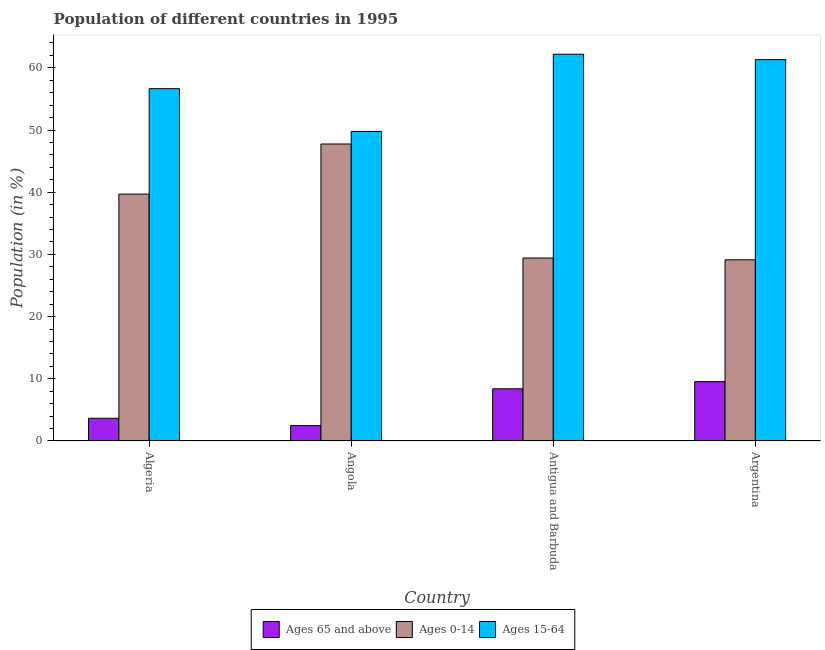How many groups of bars are there?
Your answer should be compact. 4. Are the number of bars on each tick of the X-axis equal?
Provide a short and direct response. Yes. How many bars are there on the 2nd tick from the left?
Offer a very short reply. 3. What is the label of the 2nd group of bars from the left?
Give a very brief answer. Angola. What is the percentage of population within the age-group 0-14 in Argentina?
Give a very brief answer. 29.13. Across all countries, what is the maximum percentage of population within the age-group 0-14?
Keep it short and to the point. 47.75. Across all countries, what is the minimum percentage of population within the age-group 0-14?
Your answer should be very brief. 29.13. In which country was the percentage of population within the age-group of 65 and above maximum?
Your response must be concise. Argentina. In which country was the percentage of population within the age-group 15-64 minimum?
Ensure brevity in your answer.  Angola. What is the total percentage of population within the age-group 15-64 in the graph?
Keep it short and to the point. 229.94. What is the difference between the percentage of population within the age-group 0-14 in Angola and that in Argentina?
Give a very brief answer. 18.62. What is the difference between the percentage of population within the age-group 0-14 in Angola and the percentage of population within the age-group 15-64 in Antigua and Barbuda?
Your response must be concise. -14.44. What is the average percentage of population within the age-group of 65 and above per country?
Offer a very short reply. 6.01. What is the difference between the percentage of population within the age-group 0-14 and percentage of population within the age-group 15-64 in Antigua and Barbuda?
Give a very brief answer. -32.77. What is the ratio of the percentage of population within the age-group of 65 and above in Angola to that in Argentina?
Your answer should be compact. 0.26. Is the difference between the percentage of population within the age-group 15-64 in Algeria and Angola greater than the difference between the percentage of population within the age-group 0-14 in Algeria and Angola?
Keep it short and to the point. Yes. What is the difference between the highest and the second highest percentage of population within the age-group of 65 and above?
Offer a very short reply. 1.16. What is the difference between the highest and the lowest percentage of population within the age-group 15-64?
Offer a terse response. 12.42. In how many countries, is the percentage of population within the age-group of 65 and above greater than the average percentage of population within the age-group of 65 and above taken over all countries?
Offer a very short reply. 2. Is the sum of the percentage of population within the age-group 15-64 in Angola and Antigua and Barbuda greater than the maximum percentage of population within the age-group of 65 and above across all countries?
Your answer should be compact. Yes. What does the 2nd bar from the left in Angola represents?
Provide a short and direct response. Ages 0-14. What does the 2nd bar from the right in Algeria represents?
Make the answer very short. Ages 0-14. Is it the case that in every country, the sum of the percentage of population within the age-group of 65 and above and percentage of population within the age-group 0-14 is greater than the percentage of population within the age-group 15-64?
Your answer should be very brief. No. How many countries are there in the graph?
Your answer should be very brief. 4. What is the difference between two consecutive major ticks on the Y-axis?
Offer a terse response. 10. Are the values on the major ticks of Y-axis written in scientific E-notation?
Offer a terse response. No. Where does the legend appear in the graph?
Provide a short and direct response. Bottom center. How are the legend labels stacked?
Keep it short and to the point. Horizontal. What is the title of the graph?
Your answer should be very brief. Population of different countries in 1995. What is the label or title of the X-axis?
Offer a very short reply. Country. What is the label or title of the Y-axis?
Make the answer very short. Population (in %). What is the Population (in %) of Ages 65 and above in Algeria?
Give a very brief answer. 3.65. What is the Population (in %) of Ages 0-14 in Algeria?
Provide a short and direct response. 39.7. What is the Population (in %) in Ages 15-64 in Algeria?
Give a very brief answer. 56.65. What is the Population (in %) of Ages 65 and above in Angola?
Your answer should be very brief. 2.47. What is the Population (in %) in Ages 0-14 in Angola?
Give a very brief answer. 47.75. What is the Population (in %) of Ages 15-64 in Angola?
Offer a very short reply. 49.78. What is the Population (in %) of Ages 65 and above in Antigua and Barbuda?
Offer a terse response. 8.39. What is the Population (in %) of Ages 0-14 in Antigua and Barbuda?
Offer a very short reply. 29.42. What is the Population (in %) in Ages 15-64 in Antigua and Barbuda?
Your answer should be very brief. 62.19. What is the Population (in %) of Ages 65 and above in Argentina?
Your response must be concise. 9.55. What is the Population (in %) of Ages 0-14 in Argentina?
Provide a short and direct response. 29.13. What is the Population (in %) in Ages 15-64 in Argentina?
Your answer should be compact. 61.32. Across all countries, what is the maximum Population (in %) of Ages 65 and above?
Provide a short and direct response. 9.55. Across all countries, what is the maximum Population (in %) in Ages 0-14?
Your response must be concise. 47.75. Across all countries, what is the maximum Population (in %) in Ages 15-64?
Make the answer very short. 62.19. Across all countries, what is the minimum Population (in %) in Ages 65 and above?
Your answer should be very brief. 2.47. Across all countries, what is the minimum Population (in %) in Ages 0-14?
Provide a succinct answer. 29.13. Across all countries, what is the minimum Population (in %) in Ages 15-64?
Make the answer very short. 49.78. What is the total Population (in %) of Ages 65 and above in the graph?
Offer a very short reply. 24.06. What is the total Population (in %) of Ages 0-14 in the graph?
Give a very brief answer. 146. What is the total Population (in %) of Ages 15-64 in the graph?
Your response must be concise. 229.94. What is the difference between the Population (in %) in Ages 65 and above in Algeria and that in Angola?
Give a very brief answer. 1.18. What is the difference between the Population (in %) in Ages 0-14 in Algeria and that in Angola?
Keep it short and to the point. -8.06. What is the difference between the Population (in %) in Ages 15-64 in Algeria and that in Angola?
Your response must be concise. 6.88. What is the difference between the Population (in %) in Ages 65 and above in Algeria and that in Antigua and Barbuda?
Your answer should be compact. -4.74. What is the difference between the Population (in %) in Ages 0-14 in Algeria and that in Antigua and Barbuda?
Give a very brief answer. 10.28. What is the difference between the Population (in %) of Ages 15-64 in Algeria and that in Antigua and Barbuda?
Keep it short and to the point. -5.54. What is the difference between the Population (in %) in Ages 65 and above in Algeria and that in Argentina?
Your answer should be very brief. -5.9. What is the difference between the Population (in %) of Ages 0-14 in Algeria and that in Argentina?
Provide a short and direct response. 10.56. What is the difference between the Population (in %) in Ages 15-64 in Algeria and that in Argentina?
Provide a succinct answer. -4.67. What is the difference between the Population (in %) of Ages 65 and above in Angola and that in Antigua and Barbuda?
Provide a short and direct response. -5.92. What is the difference between the Population (in %) of Ages 0-14 in Angola and that in Antigua and Barbuda?
Offer a very short reply. 18.34. What is the difference between the Population (in %) of Ages 15-64 in Angola and that in Antigua and Barbuda?
Provide a short and direct response. -12.42. What is the difference between the Population (in %) of Ages 65 and above in Angola and that in Argentina?
Ensure brevity in your answer.  -7.08. What is the difference between the Population (in %) in Ages 0-14 in Angola and that in Argentina?
Offer a terse response. 18.62. What is the difference between the Population (in %) in Ages 15-64 in Angola and that in Argentina?
Your answer should be very brief. -11.54. What is the difference between the Population (in %) in Ages 65 and above in Antigua and Barbuda and that in Argentina?
Your answer should be compact. -1.16. What is the difference between the Population (in %) of Ages 0-14 in Antigua and Barbuda and that in Argentina?
Offer a very short reply. 0.29. What is the difference between the Population (in %) of Ages 15-64 in Antigua and Barbuda and that in Argentina?
Offer a terse response. 0.87. What is the difference between the Population (in %) in Ages 65 and above in Algeria and the Population (in %) in Ages 0-14 in Angola?
Provide a succinct answer. -44.1. What is the difference between the Population (in %) of Ages 65 and above in Algeria and the Population (in %) of Ages 15-64 in Angola?
Provide a short and direct response. -46.12. What is the difference between the Population (in %) in Ages 0-14 in Algeria and the Population (in %) in Ages 15-64 in Angola?
Your answer should be very brief. -10.08. What is the difference between the Population (in %) of Ages 65 and above in Algeria and the Population (in %) of Ages 0-14 in Antigua and Barbuda?
Provide a short and direct response. -25.77. What is the difference between the Population (in %) of Ages 65 and above in Algeria and the Population (in %) of Ages 15-64 in Antigua and Barbuda?
Ensure brevity in your answer.  -58.54. What is the difference between the Population (in %) of Ages 0-14 in Algeria and the Population (in %) of Ages 15-64 in Antigua and Barbuda?
Ensure brevity in your answer.  -22.49. What is the difference between the Population (in %) in Ages 65 and above in Algeria and the Population (in %) in Ages 0-14 in Argentina?
Ensure brevity in your answer.  -25.48. What is the difference between the Population (in %) in Ages 65 and above in Algeria and the Population (in %) in Ages 15-64 in Argentina?
Your answer should be very brief. -57.67. What is the difference between the Population (in %) in Ages 0-14 in Algeria and the Population (in %) in Ages 15-64 in Argentina?
Provide a short and direct response. -21.62. What is the difference between the Population (in %) in Ages 65 and above in Angola and the Population (in %) in Ages 0-14 in Antigua and Barbuda?
Provide a succinct answer. -26.95. What is the difference between the Population (in %) of Ages 65 and above in Angola and the Population (in %) of Ages 15-64 in Antigua and Barbuda?
Your answer should be very brief. -59.72. What is the difference between the Population (in %) in Ages 0-14 in Angola and the Population (in %) in Ages 15-64 in Antigua and Barbuda?
Ensure brevity in your answer.  -14.44. What is the difference between the Population (in %) in Ages 65 and above in Angola and the Population (in %) in Ages 0-14 in Argentina?
Make the answer very short. -26.66. What is the difference between the Population (in %) of Ages 65 and above in Angola and the Population (in %) of Ages 15-64 in Argentina?
Your answer should be very brief. -58.85. What is the difference between the Population (in %) in Ages 0-14 in Angola and the Population (in %) in Ages 15-64 in Argentina?
Ensure brevity in your answer.  -13.56. What is the difference between the Population (in %) of Ages 65 and above in Antigua and Barbuda and the Population (in %) of Ages 0-14 in Argentina?
Make the answer very short. -20.74. What is the difference between the Population (in %) of Ages 65 and above in Antigua and Barbuda and the Population (in %) of Ages 15-64 in Argentina?
Keep it short and to the point. -52.93. What is the difference between the Population (in %) of Ages 0-14 in Antigua and Barbuda and the Population (in %) of Ages 15-64 in Argentina?
Give a very brief answer. -31.9. What is the average Population (in %) of Ages 65 and above per country?
Make the answer very short. 6.01. What is the average Population (in %) of Ages 0-14 per country?
Your answer should be compact. 36.5. What is the average Population (in %) of Ages 15-64 per country?
Keep it short and to the point. 57.48. What is the difference between the Population (in %) in Ages 65 and above and Population (in %) in Ages 0-14 in Algeria?
Ensure brevity in your answer.  -36.04. What is the difference between the Population (in %) of Ages 65 and above and Population (in %) of Ages 15-64 in Algeria?
Offer a terse response. -53. What is the difference between the Population (in %) of Ages 0-14 and Population (in %) of Ages 15-64 in Algeria?
Ensure brevity in your answer.  -16.96. What is the difference between the Population (in %) in Ages 65 and above and Population (in %) in Ages 0-14 in Angola?
Make the answer very short. -45.29. What is the difference between the Population (in %) of Ages 65 and above and Population (in %) of Ages 15-64 in Angola?
Offer a very short reply. -47.31. What is the difference between the Population (in %) of Ages 0-14 and Population (in %) of Ages 15-64 in Angola?
Provide a succinct answer. -2.02. What is the difference between the Population (in %) in Ages 65 and above and Population (in %) in Ages 0-14 in Antigua and Barbuda?
Offer a very short reply. -21.03. What is the difference between the Population (in %) in Ages 65 and above and Population (in %) in Ages 15-64 in Antigua and Barbuda?
Your answer should be compact. -53.8. What is the difference between the Population (in %) of Ages 0-14 and Population (in %) of Ages 15-64 in Antigua and Barbuda?
Keep it short and to the point. -32.77. What is the difference between the Population (in %) in Ages 65 and above and Population (in %) in Ages 0-14 in Argentina?
Provide a short and direct response. -19.59. What is the difference between the Population (in %) of Ages 65 and above and Population (in %) of Ages 15-64 in Argentina?
Provide a short and direct response. -51.77. What is the difference between the Population (in %) in Ages 0-14 and Population (in %) in Ages 15-64 in Argentina?
Your answer should be very brief. -32.18. What is the ratio of the Population (in %) of Ages 65 and above in Algeria to that in Angola?
Provide a succinct answer. 1.48. What is the ratio of the Population (in %) in Ages 0-14 in Algeria to that in Angola?
Offer a very short reply. 0.83. What is the ratio of the Population (in %) in Ages 15-64 in Algeria to that in Angola?
Your answer should be very brief. 1.14. What is the ratio of the Population (in %) of Ages 65 and above in Algeria to that in Antigua and Barbuda?
Give a very brief answer. 0.44. What is the ratio of the Population (in %) of Ages 0-14 in Algeria to that in Antigua and Barbuda?
Offer a very short reply. 1.35. What is the ratio of the Population (in %) in Ages 15-64 in Algeria to that in Antigua and Barbuda?
Your response must be concise. 0.91. What is the ratio of the Population (in %) in Ages 65 and above in Algeria to that in Argentina?
Your response must be concise. 0.38. What is the ratio of the Population (in %) of Ages 0-14 in Algeria to that in Argentina?
Provide a succinct answer. 1.36. What is the ratio of the Population (in %) in Ages 15-64 in Algeria to that in Argentina?
Your answer should be very brief. 0.92. What is the ratio of the Population (in %) of Ages 65 and above in Angola to that in Antigua and Barbuda?
Your response must be concise. 0.29. What is the ratio of the Population (in %) of Ages 0-14 in Angola to that in Antigua and Barbuda?
Keep it short and to the point. 1.62. What is the ratio of the Population (in %) of Ages 15-64 in Angola to that in Antigua and Barbuda?
Give a very brief answer. 0.8. What is the ratio of the Population (in %) of Ages 65 and above in Angola to that in Argentina?
Give a very brief answer. 0.26. What is the ratio of the Population (in %) of Ages 0-14 in Angola to that in Argentina?
Ensure brevity in your answer.  1.64. What is the ratio of the Population (in %) in Ages 15-64 in Angola to that in Argentina?
Provide a short and direct response. 0.81. What is the ratio of the Population (in %) in Ages 65 and above in Antigua and Barbuda to that in Argentina?
Give a very brief answer. 0.88. What is the ratio of the Population (in %) of Ages 0-14 in Antigua and Barbuda to that in Argentina?
Provide a short and direct response. 1.01. What is the ratio of the Population (in %) in Ages 15-64 in Antigua and Barbuda to that in Argentina?
Your answer should be compact. 1.01. What is the difference between the highest and the second highest Population (in %) of Ages 65 and above?
Offer a terse response. 1.16. What is the difference between the highest and the second highest Population (in %) in Ages 0-14?
Your response must be concise. 8.06. What is the difference between the highest and the second highest Population (in %) of Ages 15-64?
Make the answer very short. 0.87. What is the difference between the highest and the lowest Population (in %) in Ages 65 and above?
Your answer should be very brief. 7.08. What is the difference between the highest and the lowest Population (in %) of Ages 0-14?
Make the answer very short. 18.62. What is the difference between the highest and the lowest Population (in %) of Ages 15-64?
Make the answer very short. 12.42. 